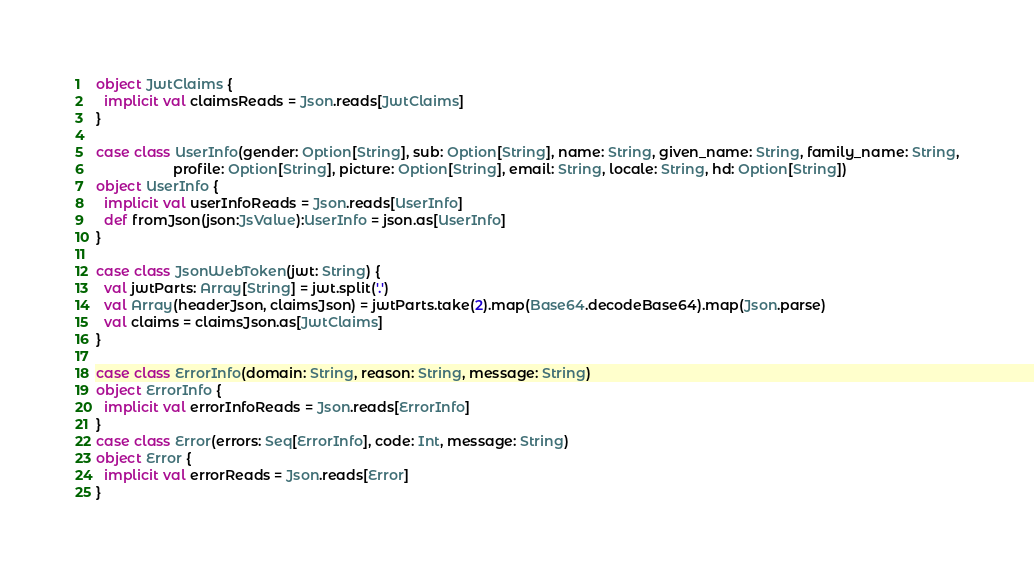Convert code to text. <code><loc_0><loc_0><loc_500><loc_500><_Scala_>object JwtClaims {
  implicit val claimsReads = Json.reads[JwtClaims]
}

case class UserInfo(gender: Option[String], sub: Option[String], name: String, given_name: String, family_name: String,
                    profile: Option[String], picture: Option[String], email: String, locale: String, hd: Option[String])
object UserInfo {
  implicit val userInfoReads = Json.reads[UserInfo]
  def fromJson(json:JsValue):UserInfo = json.as[UserInfo]
}

case class JsonWebToken(jwt: String) {
  val jwtParts: Array[String] = jwt.split('.')
  val Array(headerJson, claimsJson) = jwtParts.take(2).map(Base64.decodeBase64).map(Json.parse)
  val claims = claimsJson.as[JwtClaims]
}

case class ErrorInfo(domain: String, reason: String, message: String)
object ErrorInfo {
  implicit val errorInfoReads = Json.reads[ErrorInfo]
}
case class Error(errors: Seq[ErrorInfo], code: Int, message: String)
object Error {
  implicit val errorReads = Json.reads[Error]
}
</code> 